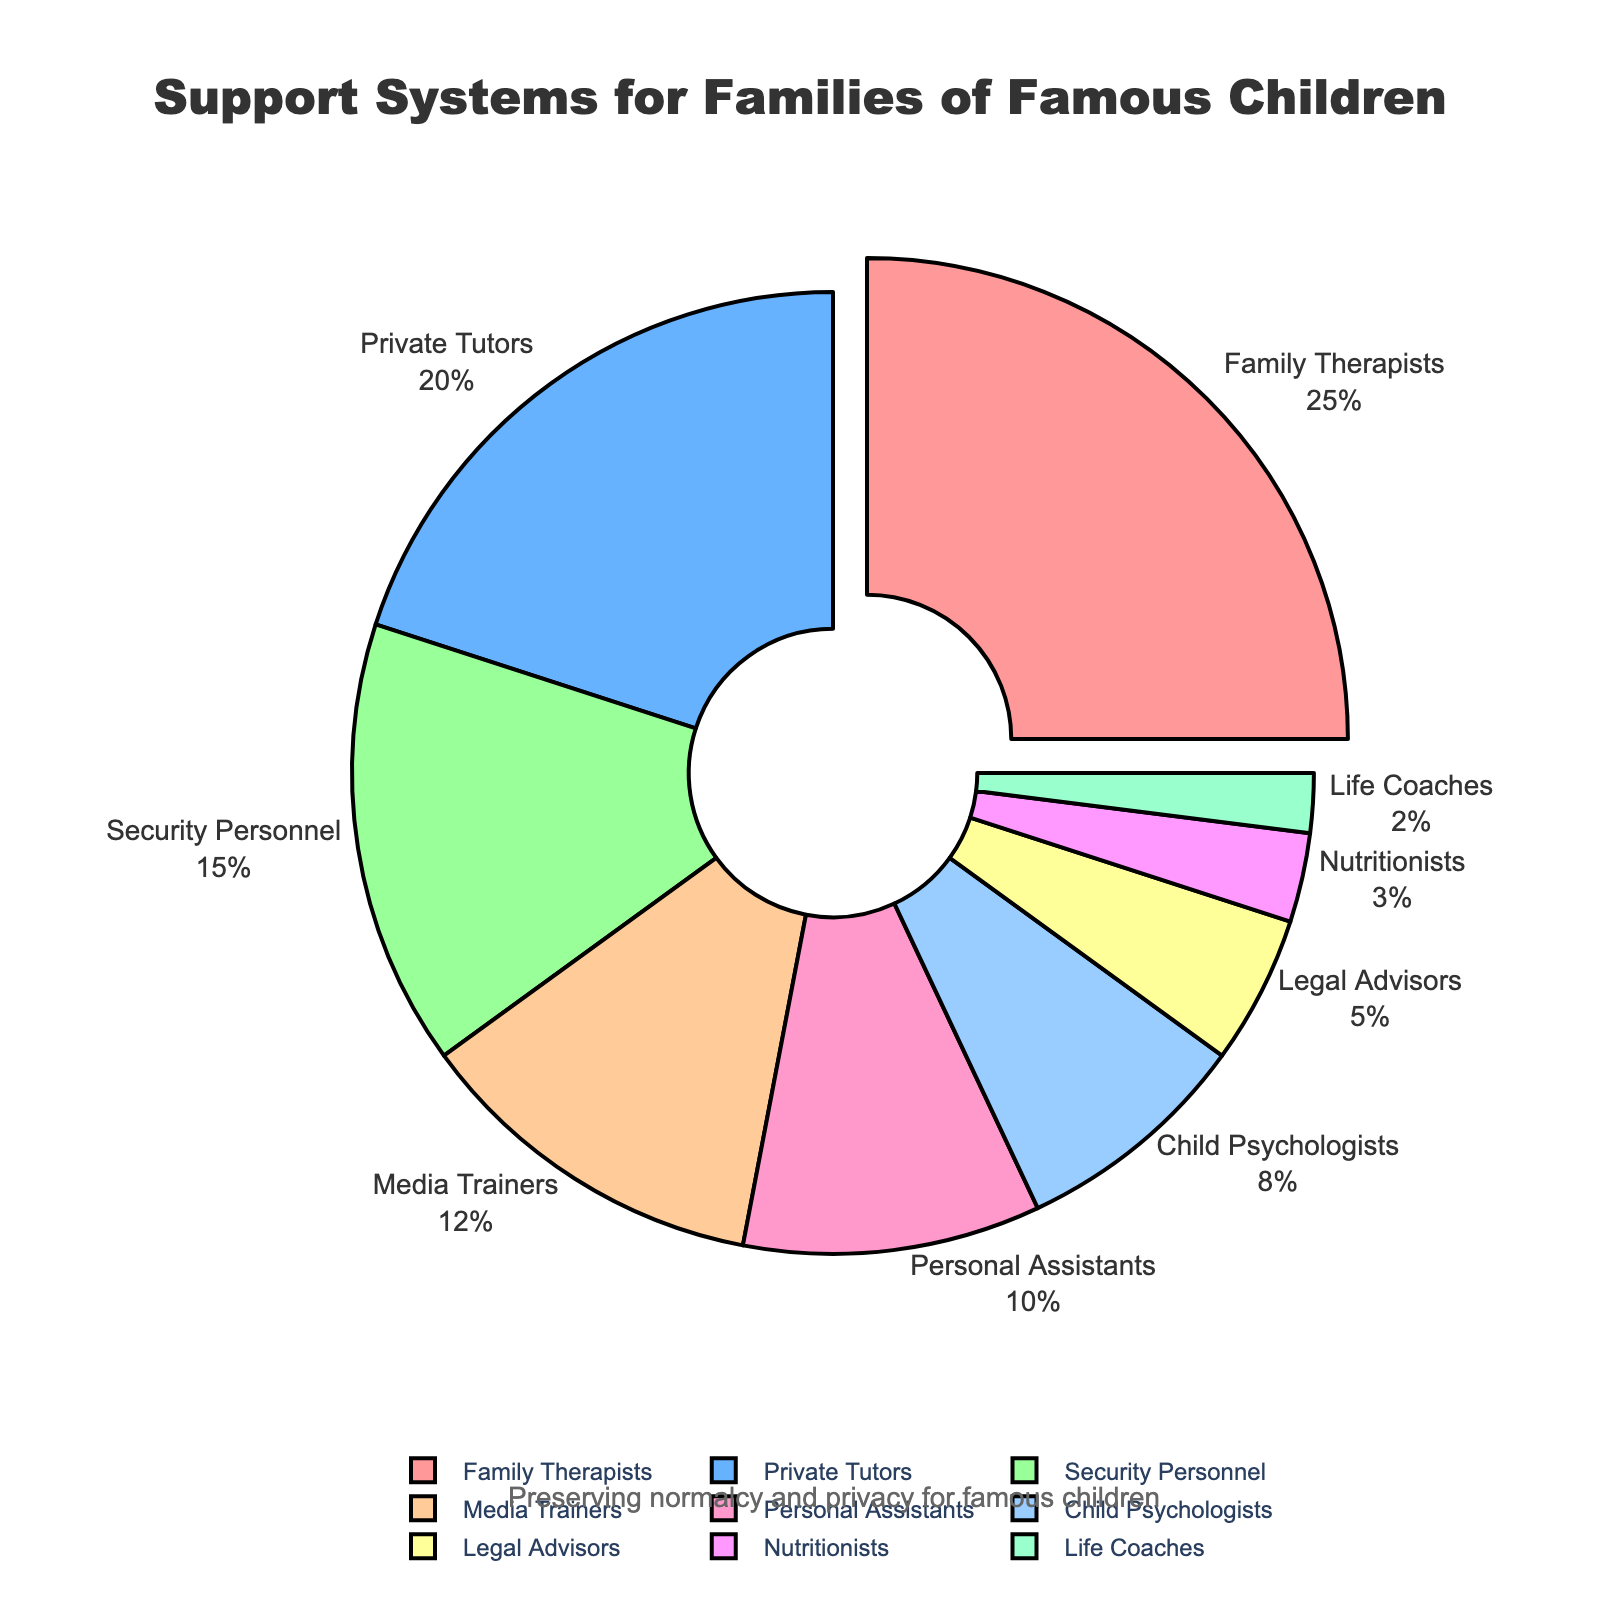Which support system is utilized the most by families of famous children? To find which support system is utilized the most, we look at the segment of the pie chart that represents the largest portion. The largest segment is for Family Therapists.
Answer: Family Therapists What is the combined percentage of families using Private Tutors and Security Personnel? To find the combined percentage, we add the percentages of Private Tutors (20%) and Security Personnel (15%). 20% + 15% = 35%.
Answer: 35% Which support system has a higher percentage, Child Psychologists or Personal Assistants? To determine which has a higher percentage, we compare the percentages of Child Psychologists (8%) and Personal Assistants (10%). Personal Assistants has a higher percentage.
Answer: Personal Assistants How much more percentage do Family Therapists have compared to Media Trainers? We need to find the difference between the percentages of Family Therapists (25%) and Media Trainers (12%). 25% - 12% = 13%.
Answer: 13% What is the total percentage of support systems each utilized by 10% or less of families? We need to sum the percentages of Personal Assistants (10%), Child Psychologists (8%), Legal Advisors (5%), Nutritionists (3%), and Life Coaches (2%). 10% + 8% + 5% + 3% + 2% = 28%.
Answer: 28% Which support system is represented by the smallest segment in the pie chart? The smallest segment in the pie chart corresponds to the support system with the lowest percentage. Life Coaches have the smallest segment.
Answer: Life Coaches What is the percentage difference between Private Tutors and Legal Advisors? To find the percentage difference, we subtract the higher percentage (Private Tutors, 20%) from the lower percentage (Legal Advisors, 5%). 20% - 5% = 15%.
Answer: 15% Compare the percentage of families using Media Trainers to those using Security Personnel. Which one is greater? By comparing the percentages of Media Trainers (12%) and Security Personnel (15%), we find that Security Personnel is greater.
Answer: Security Personnel 